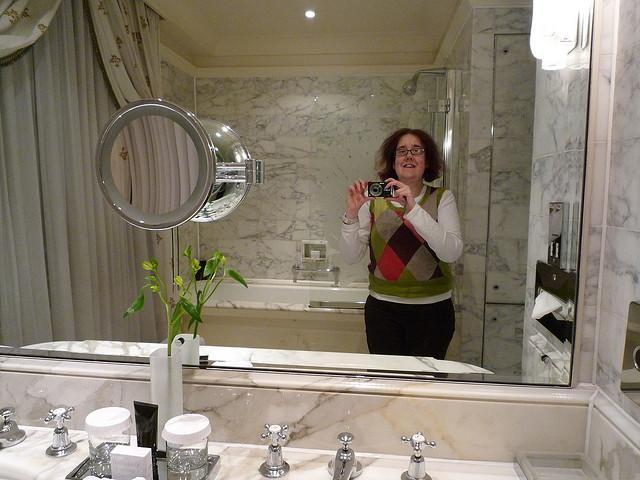What type of shower head is in the background?

Choices:
A) removable
B) wall mount
C) rainfall
D) underwater wall mount 